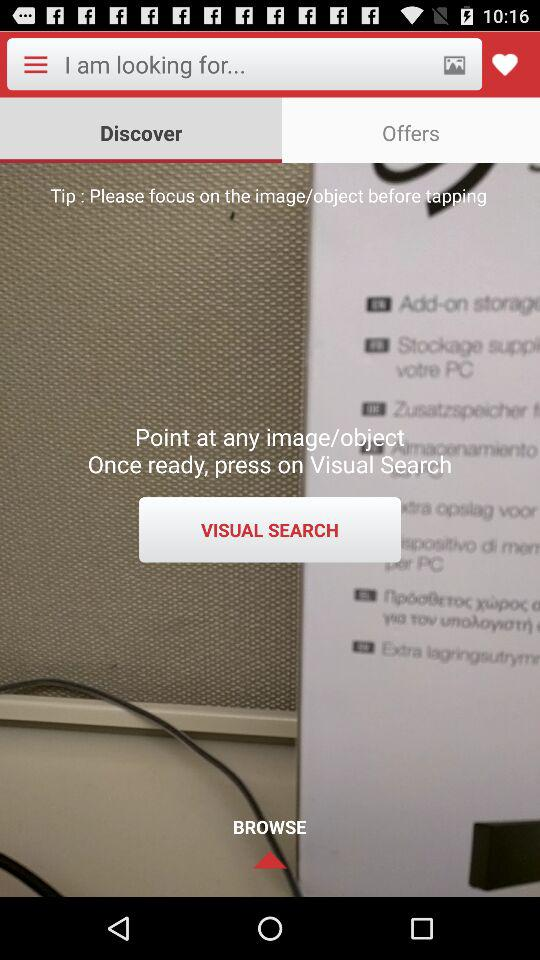What tab has been selected? The tab that has been selected is "Discover". 